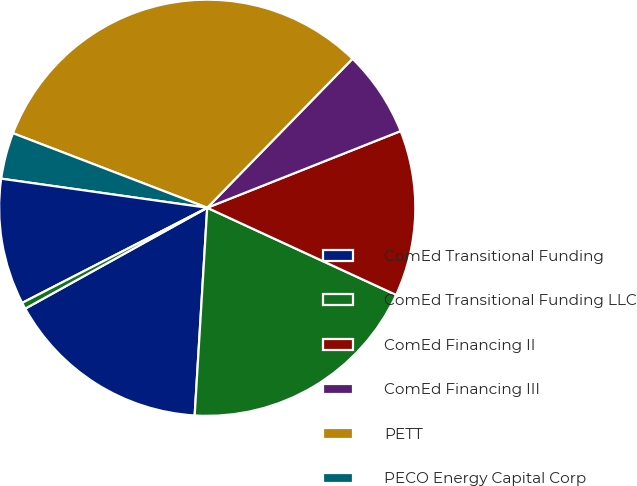Convert chart. <chart><loc_0><loc_0><loc_500><loc_500><pie_chart><fcel>ComEd Transitional Funding<fcel>ComEd Transitional Funding LLC<fcel>ComEd Financing II<fcel>ComEd Financing III<fcel>PETT<fcel>PECO Energy Capital Corp<fcel>PECO Trust IV<fcel>PECO Trust III<nl><fcel>15.98%<fcel>19.08%<fcel>12.89%<fcel>6.69%<fcel>31.47%<fcel>3.6%<fcel>9.79%<fcel>0.5%<nl></chart> 